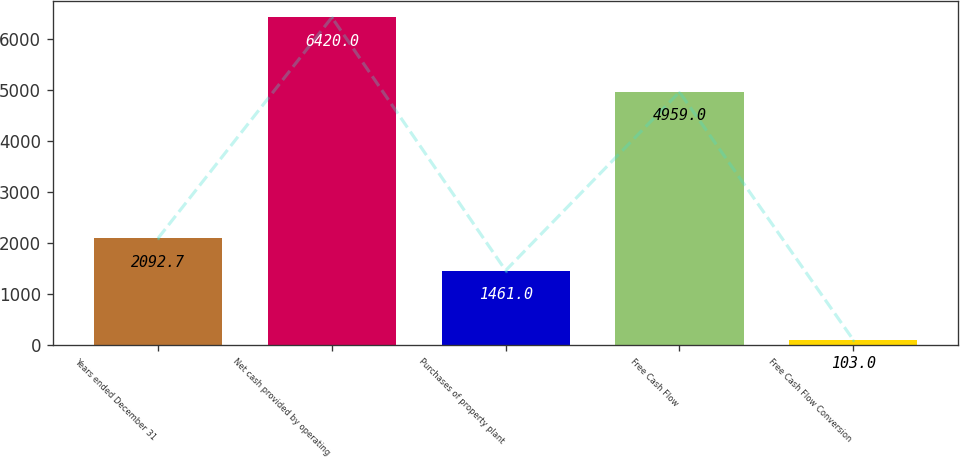Convert chart to OTSL. <chart><loc_0><loc_0><loc_500><loc_500><bar_chart><fcel>Years ended December 31<fcel>Net cash provided by operating<fcel>Purchases of property plant<fcel>Free Cash Flow<fcel>Free Cash Flow Conversion<nl><fcel>2092.7<fcel>6420<fcel>1461<fcel>4959<fcel>103<nl></chart> 